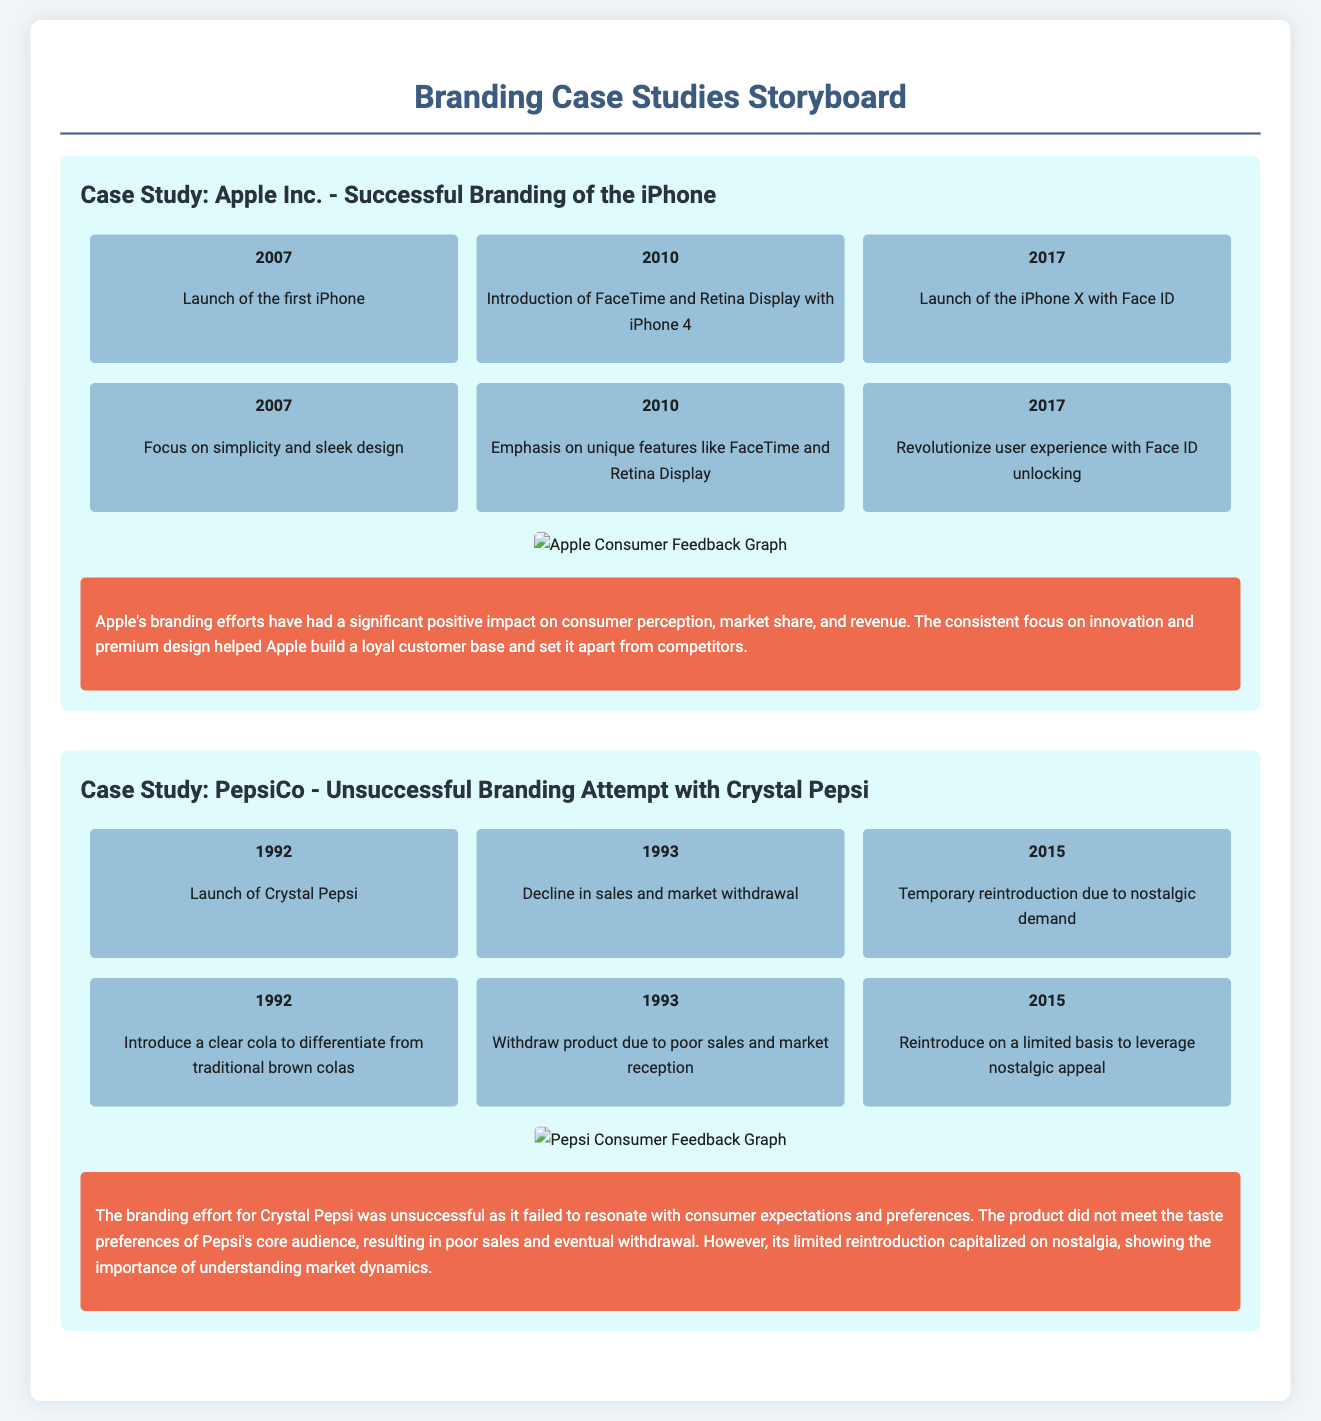what year was the first iPhone launched? The document states that the first iPhone was launched in 2007.
Answer: 2007 what were the unique features introduced with the iPhone 4? The document mentions that FaceTime and Retina Display were introduced with the iPhone 4 in 2010.
Answer: FaceTime and Retina Display what is the main reason for the withdrawal of Crystal Pepsi? The document explains that poor sales and market reception led to the withdrawal of Crystal Pepsi in 1993.
Answer: Poor sales how did Apple's branding efforts impact consumer perception? The document states that Apple's branding efforts had a significant positive impact on consumer perception, market share, and revenue.
Answer: Positive impact what was the decision made by PepsiCo in 2015 regarding Crystal Pepsi? The document notes that PepsiCo decided to reintroduce Crystal Pepsi on a limited basis to leverage nostalgic appeal.
Answer: Reintroduce on a limited basis what was a key decision point for Apple in 2017? The document describes the 2017 decision to revolutionize user experience with Face ID unlocking as a key decision point for Apple.
Answer: Revolutionize user experience how many events are listed in the timeline for the Crystal Pepsi case study? The document lists three events in the timeline for the Crystal Pepsi case study.
Answer: Three events what is included in the feedback graph section of the case studies? The document shows that each case study includes a consumer feedback graph image.
Answer: Consumer feedback graph image what color is used for the impact assessment of the PepsiCo case study? The document indicates that the impact assessment for the PepsiCo case study is in the color white.
Answer: White 